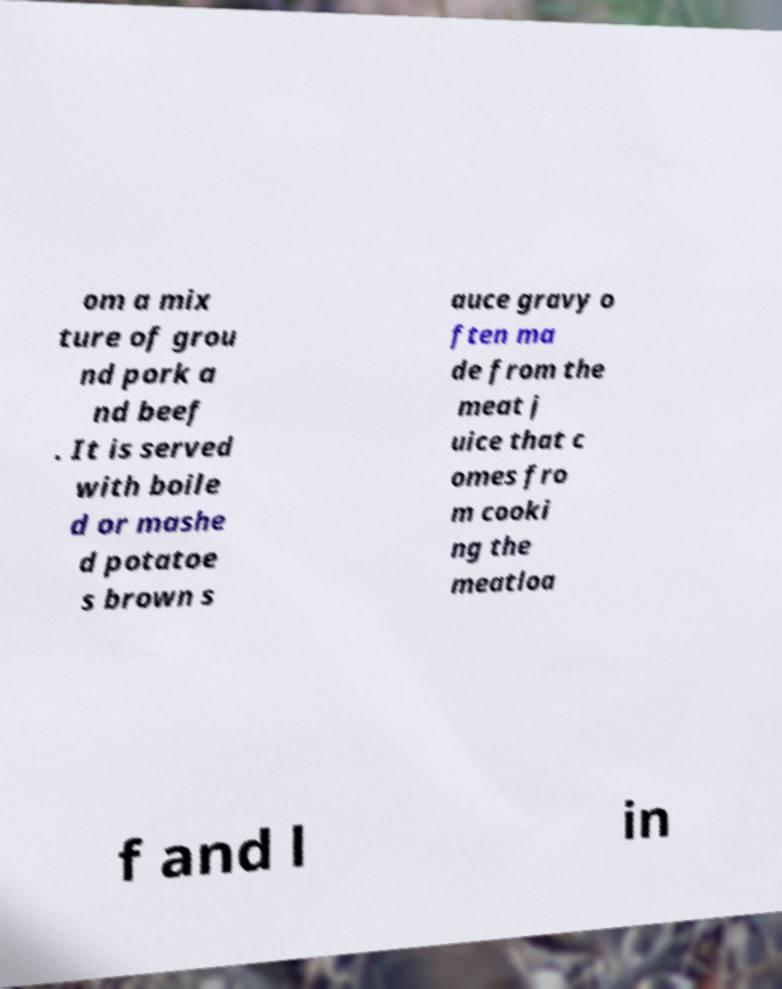Could you extract and type out the text from this image? om a mix ture of grou nd pork a nd beef . It is served with boile d or mashe d potatoe s brown s auce gravy o ften ma de from the meat j uice that c omes fro m cooki ng the meatloa f and l in 